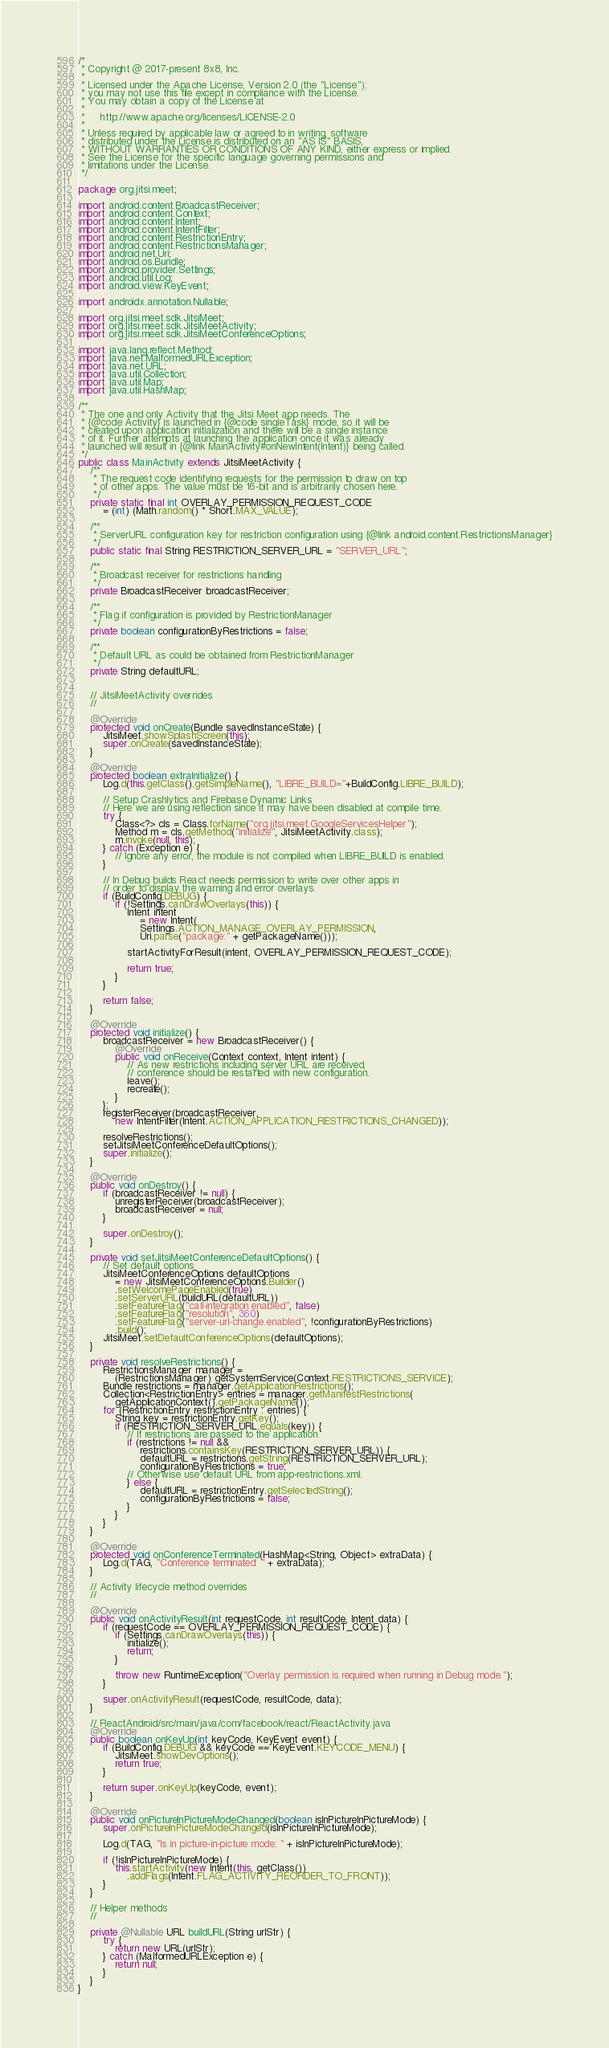<code> <loc_0><loc_0><loc_500><loc_500><_Java_>/*
 * Copyright @ 2017-present 8x8, Inc.
 *
 * Licensed under the Apache License, Version 2.0 (the "License");
 * you may not use this file except in compliance with the License.
 * You may obtain a copy of the License at
 *
 *     http://www.apache.org/licenses/LICENSE-2.0
 *
 * Unless required by applicable law or agreed to in writing, software
 * distributed under the License is distributed on an "AS IS" BASIS,
 * WITHOUT WARRANTIES OR CONDITIONS OF ANY KIND, either express or implied.
 * See the License for the specific language governing permissions and
 * limitations under the License.
 */

package org.jitsi.meet;

import android.content.BroadcastReceiver;
import android.content.Context;
import android.content.Intent;
import android.content.IntentFilter;
import android.content.RestrictionEntry;
import android.content.RestrictionsManager;
import android.net.Uri;
import android.os.Bundle;
import android.provider.Settings;
import android.util.Log;
import android.view.KeyEvent;

import androidx.annotation.Nullable;

import org.jitsi.meet.sdk.JitsiMeet;
import org.jitsi.meet.sdk.JitsiMeetActivity;
import org.jitsi.meet.sdk.JitsiMeetConferenceOptions;

import java.lang.reflect.Method;
import java.net.MalformedURLException;
import java.net.URL;
import java.util.Collection;
import java.util.Map;
import java.util.HashMap;

/**
 * The one and only Activity that the Jitsi Meet app needs. The
 * {@code Activity} is launched in {@code singleTask} mode, so it will be
 * created upon application initialization and there will be a single instance
 * of it. Further attempts at launching the application once it was already
 * launched will result in {@link MainActivity#onNewIntent(Intent)} being called.
 */
public class MainActivity extends JitsiMeetActivity {
    /**
     * The request code identifying requests for the permission to draw on top
     * of other apps. The value must be 16-bit and is arbitrarily chosen here.
     */
    private static final int OVERLAY_PERMISSION_REQUEST_CODE
        = (int) (Math.random() * Short.MAX_VALUE);

    /**
     * ServerURL configuration key for restriction configuration using {@link android.content.RestrictionsManager}
     */
    public static final String RESTRICTION_SERVER_URL = "SERVER_URL";

    /**
     * Broadcast receiver for restrictions handling
     */
    private BroadcastReceiver broadcastReceiver;

    /**
     * Flag if configuration is provided by RestrictionManager
     */
    private boolean configurationByRestrictions = false;

    /**
     * Default URL as could be obtained from RestrictionManager
     */
    private String defaultURL;


    // JitsiMeetActivity overrides
    //

    @Override
    protected void onCreate(Bundle savedInstanceState) {
        JitsiMeet.showSplashScreen(this);
        super.onCreate(savedInstanceState);
    }

    @Override
    protected boolean extraInitialize() {
        Log.d(this.getClass().getSimpleName(), "LIBRE_BUILD="+BuildConfig.LIBRE_BUILD);

        // Setup Crashlytics and Firebase Dynamic Links
        // Here we are using reflection since it may have been disabled at compile time.
        try {
            Class<?> cls = Class.forName("org.jitsi.meet.GoogleServicesHelper");
            Method m = cls.getMethod("initialize", JitsiMeetActivity.class);
            m.invoke(null, this);
        } catch (Exception e) {
            // Ignore any error, the module is not compiled when LIBRE_BUILD is enabled.
        }

        // In Debug builds React needs permission to write over other apps in
        // order to display the warning and error overlays.
        if (BuildConfig.DEBUG) {
            if (!Settings.canDrawOverlays(this)) {
                Intent intent
                    = new Intent(
                    Settings.ACTION_MANAGE_OVERLAY_PERMISSION,
                    Uri.parse("package:" + getPackageName()));

                startActivityForResult(intent, OVERLAY_PERMISSION_REQUEST_CODE);

                return true;
            }
        }

        return false;
    }

    @Override
    protected void initialize() {
        broadcastReceiver = new BroadcastReceiver() {
            @Override
            public void onReceive(Context context, Intent intent) {
                // As new restrictions including server URL are received,
                // conference should be restarted with new configuration.
                leave();
                recreate();
            }
        };
        registerReceiver(broadcastReceiver,
            new IntentFilter(Intent.ACTION_APPLICATION_RESTRICTIONS_CHANGED));

        resolveRestrictions();
        setJitsiMeetConferenceDefaultOptions();
        super.initialize();
    }

    @Override
    public void onDestroy() {
        if (broadcastReceiver != null) {
            unregisterReceiver(broadcastReceiver);
            broadcastReceiver = null;
        }

        super.onDestroy();
    }

    private void setJitsiMeetConferenceDefaultOptions() {
        // Set default options
        JitsiMeetConferenceOptions defaultOptions
            = new JitsiMeetConferenceOptions.Builder()
            .setWelcomePageEnabled(true)
            .setServerURL(buildURL(defaultURL))
            .setFeatureFlag("call-integration.enabled", false)
            .setFeatureFlag("resolution", 360)
            .setFeatureFlag("server-url-change.enabled", !configurationByRestrictions)
            .build();
        JitsiMeet.setDefaultConferenceOptions(defaultOptions);
    }

    private void resolveRestrictions() {
        RestrictionsManager manager =
            (RestrictionsManager) getSystemService(Context.RESTRICTIONS_SERVICE);
        Bundle restrictions = manager.getApplicationRestrictions();
        Collection<RestrictionEntry> entries = manager.getManifestRestrictions(
            getApplicationContext().getPackageName());
        for (RestrictionEntry restrictionEntry : entries) {
            String key = restrictionEntry.getKey();
            if (RESTRICTION_SERVER_URL.equals(key)) {
                // If restrictions are passed to the application.
                if (restrictions != null &&
                    restrictions.containsKey(RESTRICTION_SERVER_URL)) {
                    defaultURL = restrictions.getString(RESTRICTION_SERVER_URL);
                    configurationByRestrictions = true;
                // Otherwise use default URL from app-restrictions.xml.
                } else {
                    defaultURL = restrictionEntry.getSelectedString();
                    configurationByRestrictions = false;
                }
            }
        }
    }

    @Override
    protected void onConferenceTerminated(HashMap<String, Object> extraData) {
        Log.d(TAG, "Conference terminated: " + extraData);
    }

    // Activity lifecycle method overrides
    //

    @Override
    public void onActivityResult(int requestCode, int resultCode, Intent data) {
        if (requestCode == OVERLAY_PERMISSION_REQUEST_CODE) {
            if (Settings.canDrawOverlays(this)) {
                initialize();
                return;
            }

            throw new RuntimeException("Overlay permission is required when running in Debug mode.");
        }

        super.onActivityResult(requestCode, resultCode, data);
    }

    // ReactAndroid/src/main/java/com/facebook/react/ReactActivity.java
    @Override
    public boolean onKeyUp(int keyCode, KeyEvent event) {
        if (BuildConfig.DEBUG && keyCode == KeyEvent.KEYCODE_MENU) {
            JitsiMeet.showDevOptions();
            return true;
        }

        return super.onKeyUp(keyCode, event);
    }

    @Override
    public void onPictureInPictureModeChanged(boolean isInPictureInPictureMode) {
        super.onPictureInPictureModeChanged(isInPictureInPictureMode);

        Log.d(TAG, "Is in picture-in-picture mode: " + isInPictureInPictureMode);

        if (!isInPictureInPictureMode) {
            this.startActivity(new Intent(this, getClass())
                .addFlags(Intent.FLAG_ACTIVITY_REORDER_TO_FRONT));
        }
    }

    // Helper methods
    //

    private @Nullable URL buildURL(String urlStr) {
        try {
            return new URL(urlStr);
        } catch (MalformedURLException e) {
            return null;
        }
    }
}
</code> 